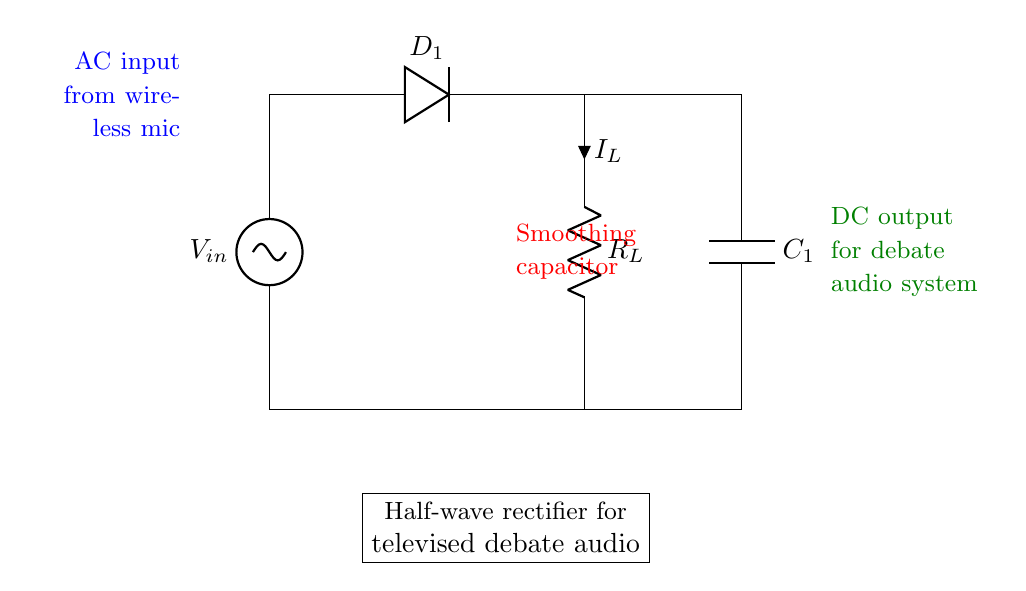What type of rectifier is shown in the diagram? The circuit is identified as a half-wave rectifier based on the presence of a single diode that allows current to pass only during one half of the input AC cycle.
Answer: Half-wave rectifier What does the smoothing capacitor do? The smoothing capacitor, connected parallel to the load resistor, reduces voltage fluctuations in the output, providing a more stable DC voltage suitable for powering devices like wireless microphones.
Answer: Reduces voltage fluctuations What is the role of the diode in the circuit? The diode in the circuit allows current to flow only in one direction, thereby converting AC voltage into pulsed DC voltage, which is essential for powering the audio equipment during debates.
Answer: Converts AC to DC What is the load resistor labeled as? The load resistor in the circuit is labeled as R_L, which signifies its role in limiting the current flowing to the connected load, in this case, the wireless microphones.
Answer: R_L What kind of input does this rectifier accept? The rectifier accepts an alternating current (AC) input as indicated by the label on the voltage source, which is necessary for the function of the rectifier to convert it into DC.
Answer: AC input What type of output does this circuit provide? The output from the circuit is direct current (DC), as noted by the label specifying that it powers the debate audio system, essential for clear sound during televised debates.
Answer: DC output 